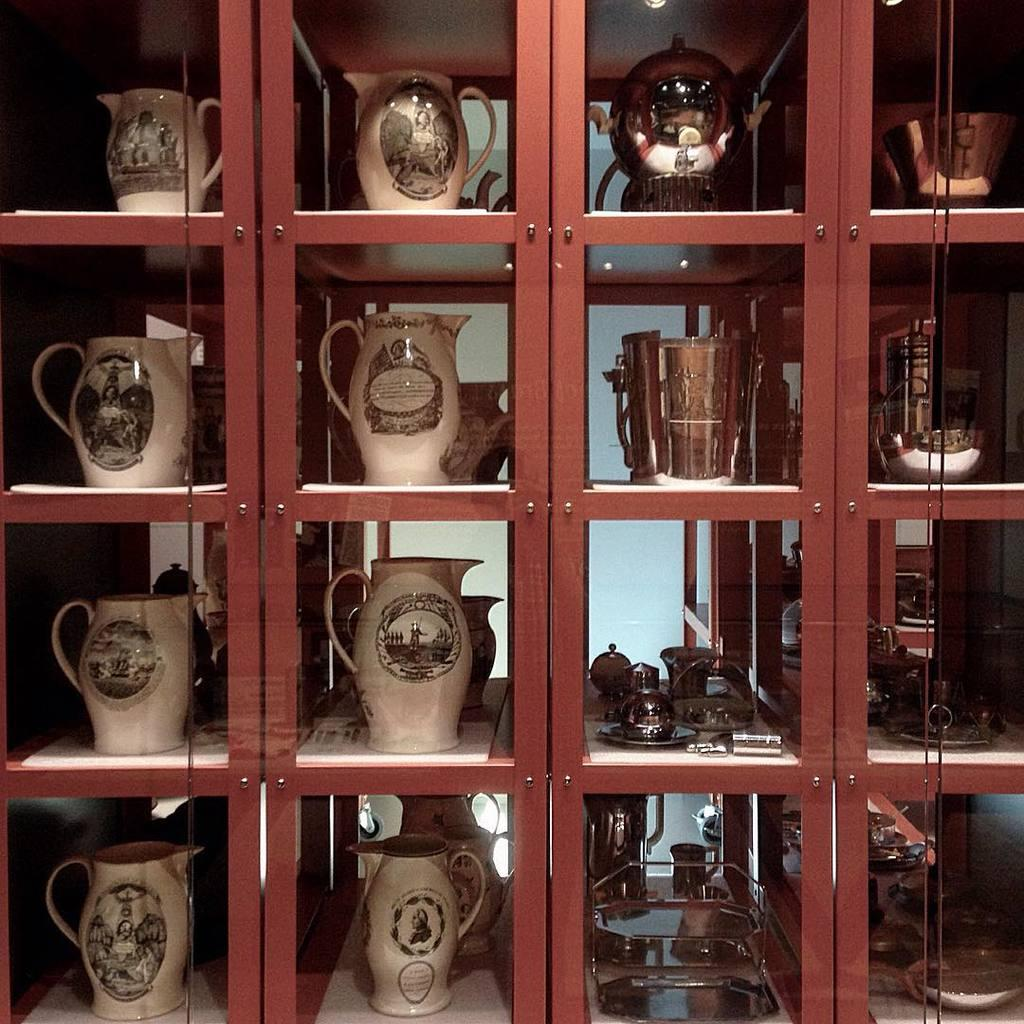What type of furniture is present in the image? There is a cupboard in the image. What is stored inside the cupboard? The cupboard contains jugs. Can you see a yak carrying a bag in the image? No, there is no yak or bag present in the image. 